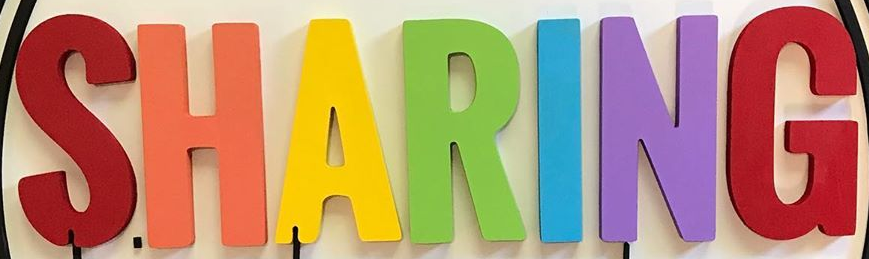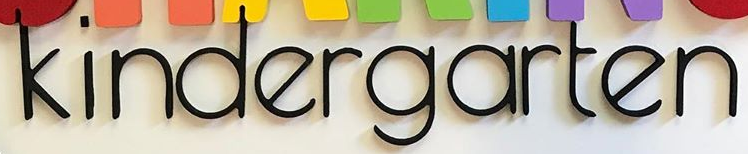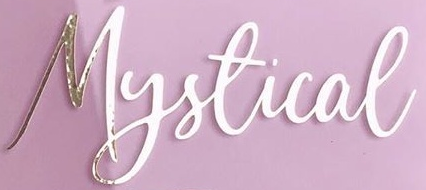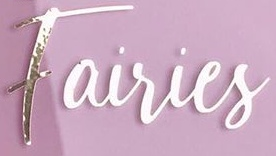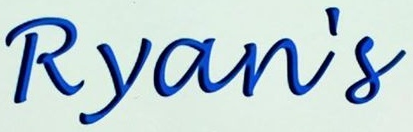Identify the words shown in these images in order, separated by a semicolon. SHARING; kindergarten; Mystical; Fairies; Ryan's 